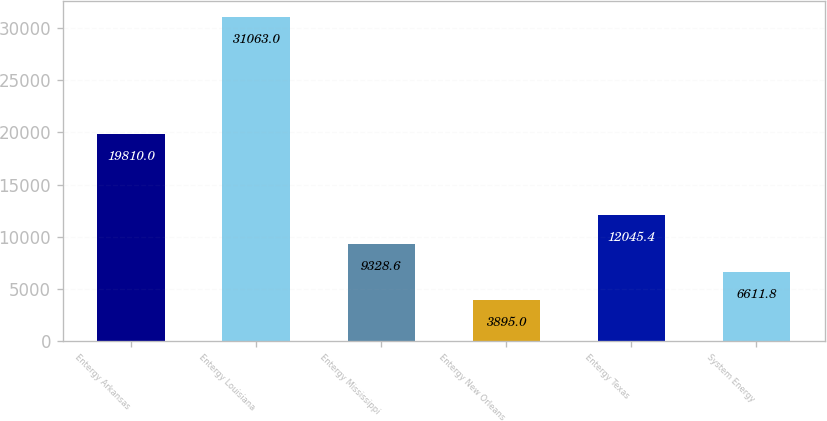Convert chart. <chart><loc_0><loc_0><loc_500><loc_500><bar_chart><fcel>Entergy Arkansas<fcel>Entergy Louisiana<fcel>Entergy Mississippi<fcel>Entergy New Orleans<fcel>Entergy Texas<fcel>System Energy<nl><fcel>19810<fcel>31063<fcel>9328.6<fcel>3895<fcel>12045.4<fcel>6611.8<nl></chart> 